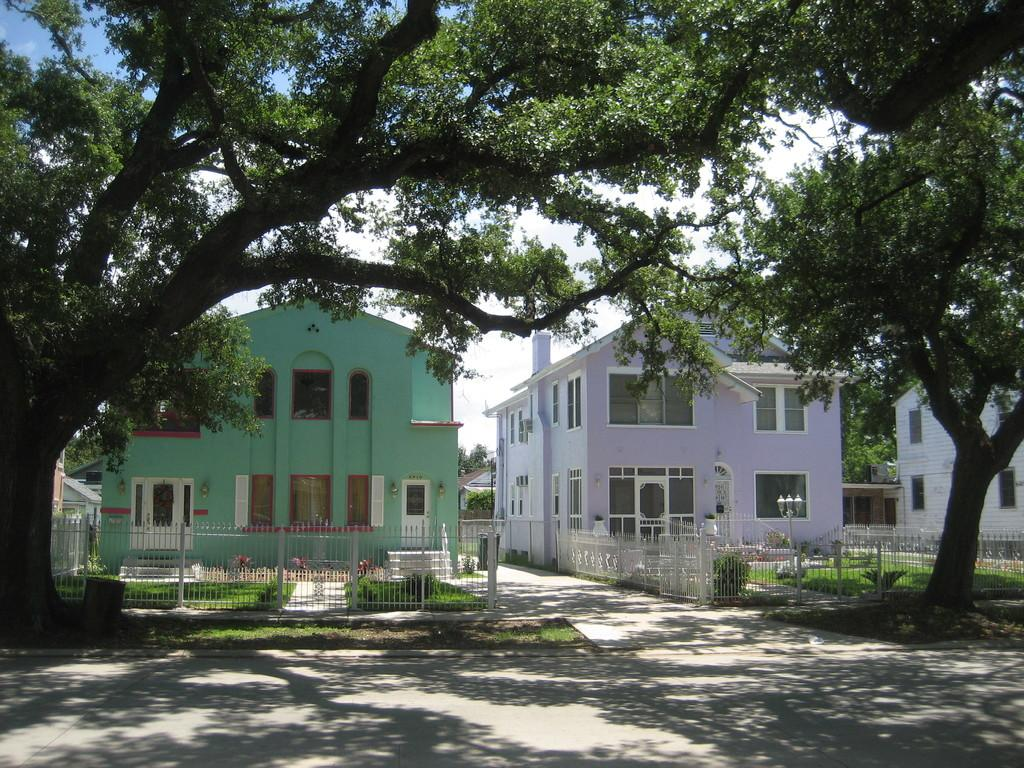What is located in the center of the image? There are buildings in the center of the image. What can be seen at the bottom of the image? Trees and a fence are visible at the bottom of the image. What is visible in the background of the image? The sky is visible in the background of the image. Can you tell me how many clams are sitting on the fence in the image? There are no clams present in the image; the fence is near the trees at the bottom of the image. What type of unit is being used to measure the height of the buildings in the image? The provided facts do not mention any specific unit of measurement for the buildings' height. 